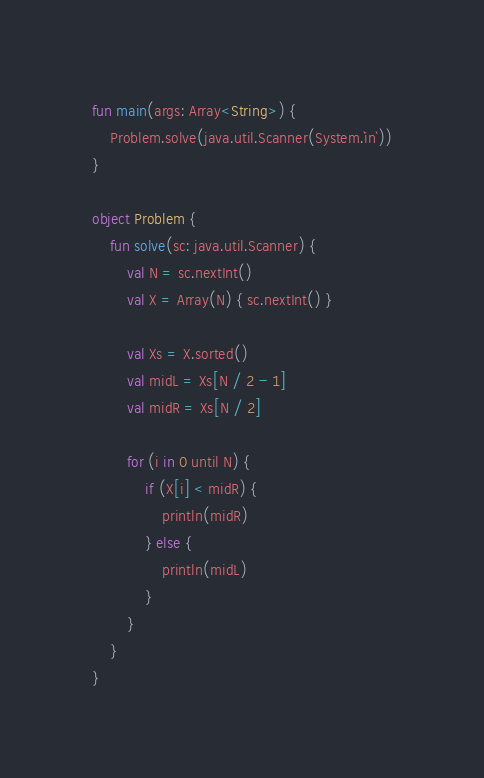Convert code to text. <code><loc_0><loc_0><loc_500><loc_500><_Kotlin_>fun main(args: Array<String>) {
    Problem.solve(java.util.Scanner(System.`in`))
}

object Problem {
    fun solve(sc: java.util.Scanner) {
        val N = sc.nextInt()
        val X = Array(N) { sc.nextInt() }

        val Xs = X.sorted()
        val midL = Xs[N / 2 - 1]
        val midR = Xs[N / 2]

        for (i in 0 until N) {
            if (X[i] < midR) {
                println(midR)
            } else {
                println(midL)
            }
        }
    }
}
</code> 